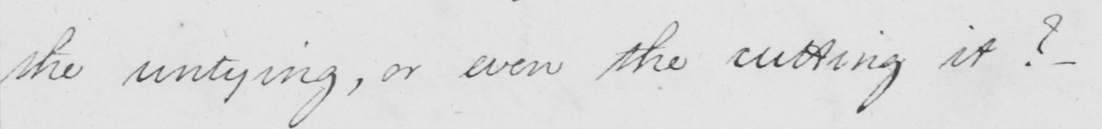Can you read and transcribe this handwriting? the untying , or even the cutting it ?  _ 